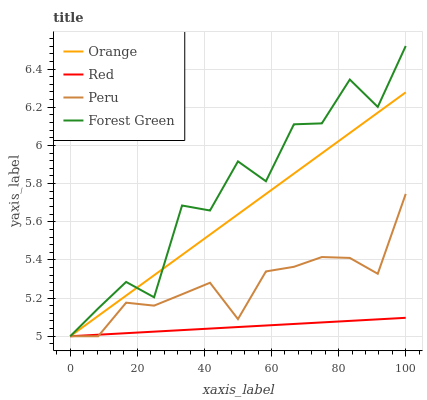Does Red have the minimum area under the curve?
Answer yes or no. Yes. Does Forest Green have the maximum area under the curve?
Answer yes or no. Yes. Does Peru have the minimum area under the curve?
Answer yes or no. No. Does Peru have the maximum area under the curve?
Answer yes or no. No. Is Red the smoothest?
Answer yes or no. Yes. Is Forest Green the roughest?
Answer yes or no. Yes. Is Peru the smoothest?
Answer yes or no. No. Is Peru the roughest?
Answer yes or no. No. Does Orange have the lowest value?
Answer yes or no. Yes. Does Forest Green have the highest value?
Answer yes or no. Yes. Does Peru have the highest value?
Answer yes or no. No. Does Peru intersect Orange?
Answer yes or no. Yes. Is Peru less than Orange?
Answer yes or no. No. Is Peru greater than Orange?
Answer yes or no. No. 